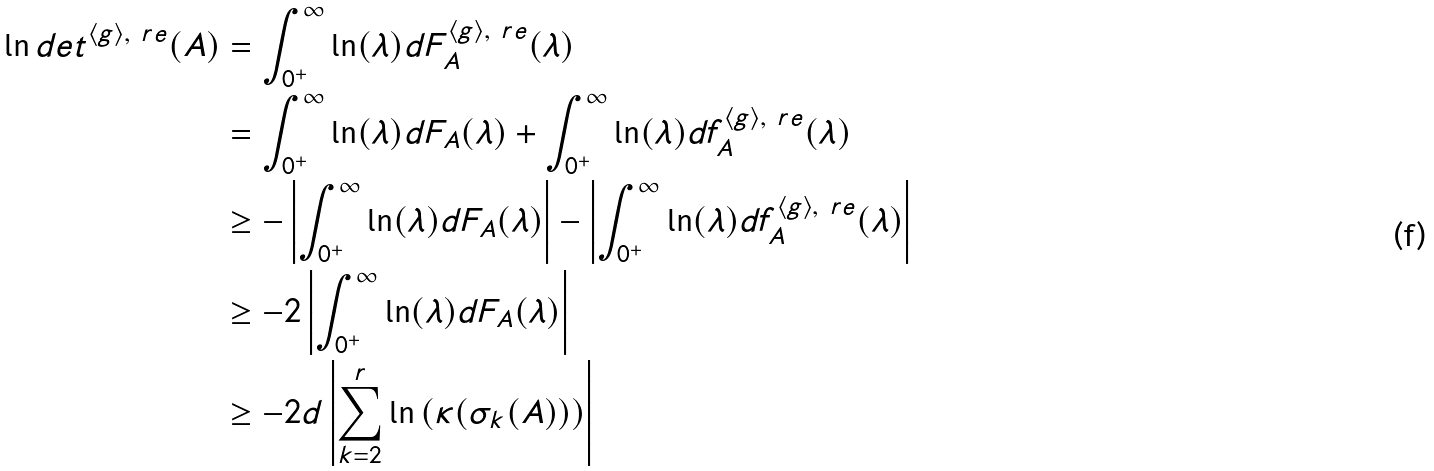<formula> <loc_0><loc_0><loc_500><loc_500>\ln d e t ^ { \langle g \rangle , \ r e } ( A ) & = \int _ { 0 ^ { + } } ^ { \infty } \ln ( \lambda ) d F _ { A } ^ { \langle g \rangle , \ r e } ( \lambda ) \\ & = \int _ { 0 ^ { + } } ^ { \infty } \ln ( \lambda ) d F _ { A } ( \lambda ) + \int _ { 0 ^ { + } } ^ { \infty } \ln ( \lambda ) d f _ { A } ^ { \langle g \rangle , \ r e } ( \lambda ) \\ & \geq - \left | \int _ { 0 ^ { + } } ^ { \infty } \ln ( \lambda ) d F _ { A } ( \lambda ) \right | - \left | \int _ { 0 ^ { + } } ^ { \infty } \ln ( \lambda ) d f _ { A } ^ { \langle g \rangle , \ r e } ( \lambda ) \right | \\ & \geq - 2 \left | \int _ { 0 ^ { + } } ^ { \infty } \ln ( \lambda ) d F _ { A } ( \lambda ) \right | \\ & \geq - 2 d \left | \sum _ { k = 2 } ^ { r } \ln \left ( \kappa ( \sigma _ { k } ( A ) ) \right ) \right |</formula> 